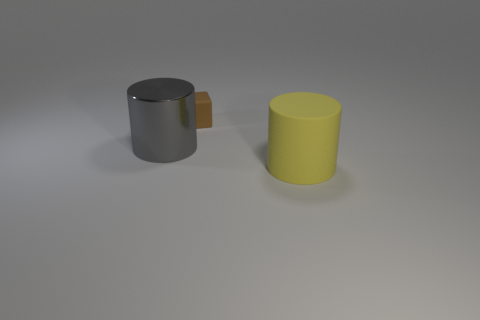What color is the other rubber thing that is the same shape as the gray thing?
Ensure brevity in your answer.  Yellow. What is the material of the yellow cylinder that is the same size as the metal thing?
Your response must be concise. Rubber. Are there any gray things that have the same shape as the large yellow rubber thing?
Offer a very short reply. Yes. What is the material of the large cylinder on the left side of the rubber object that is in front of the rubber object that is behind the rubber cylinder?
Offer a very short reply. Metal. Is there a shiny cylinder of the same size as the yellow object?
Ensure brevity in your answer.  Yes. What is the color of the tiny thing to the left of the thing right of the block?
Provide a succinct answer. Brown. How many big things are there?
Provide a short and direct response. 2. Are there fewer yellow objects that are behind the small brown rubber thing than small brown objects that are behind the big metallic object?
Provide a succinct answer. Yes. The big matte object has what color?
Ensure brevity in your answer.  Yellow. Are there any things to the right of the tiny brown matte cube?
Your response must be concise. Yes. 